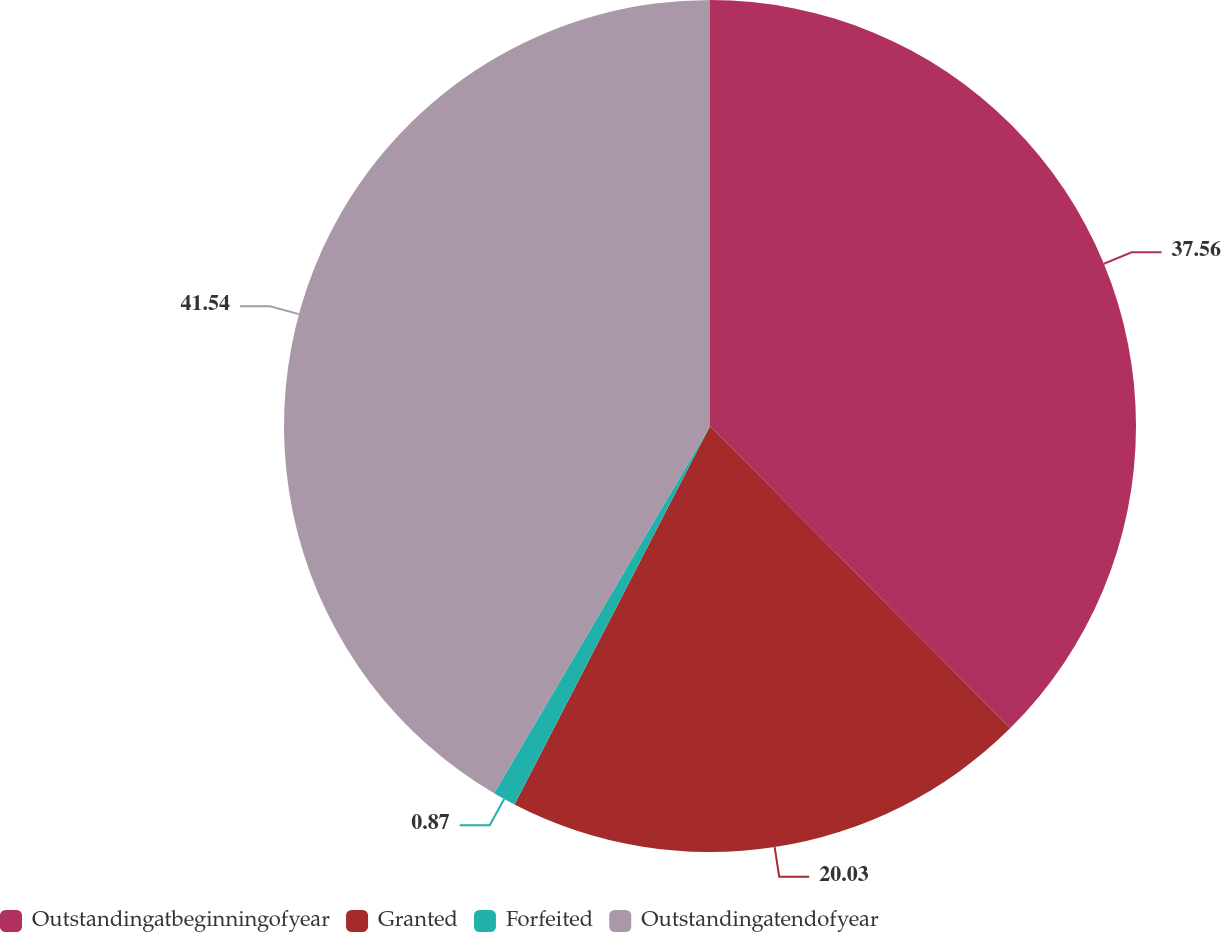<chart> <loc_0><loc_0><loc_500><loc_500><pie_chart><fcel>Outstandingatbeginningofyear<fcel>Granted<fcel>Forfeited<fcel>Outstandingatendofyear<nl><fcel>37.56%<fcel>20.03%<fcel>0.87%<fcel>41.54%<nl></chart> 